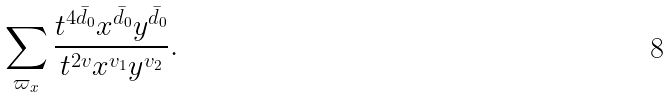Convert formula to latex. <formula><loc_0><loc_0><loc_500><loc_500>\sum _ { \varpi _ { x } } \frac { t ^ { 4 \bar { d _ { 0 } } } x ^ { \bar { d _ { 0 } } } y ^ { \bar { d _ { 0 } } } } { t ^ { 2 v } x ^ { v _ { 1 } } y ^ { v _ { 2 } } } .</formula> 